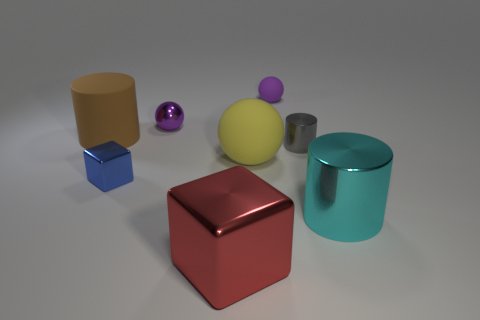What could be the purpose of this collection of objects? The arrangement and composition of the objects might serve educational purposes, such as a demonstration of lighting and shading in photography, a study of color theory, or 3D modeling. Alternatively, it could simply be an artistic display created for visual interest. 